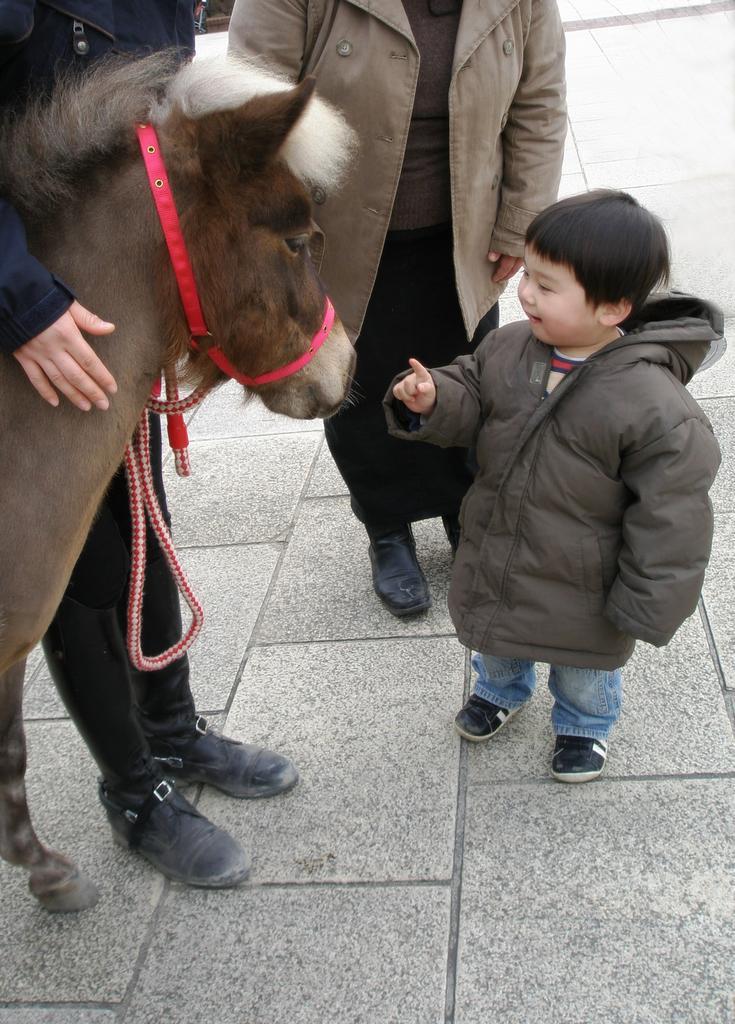In one or two sentences, can you explain what this image depicts? In this image in the front there is an animal and there is a person standing and touching the animal. In the center there are persons standing and there is a boy standing and smiling. 